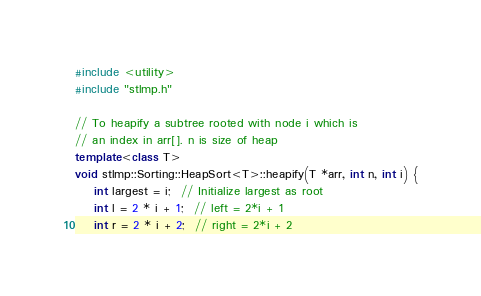Convert code to text. <code><loc_0><loc_0><loc_500><loc_500><_C++_>#include <utility>
#include "stlmp.h"

// To heapify a subtree rooted with node i which is
// an index in arr[]. n is size of heap
template<class T>
void stlmp::Sorting::HeapSort<T>::heapify(T *arr, int n, int i) {
    int largest = i;  // Initialize largest as root
    int l = 2 * i + 1;  // left = 2*i + 1
    int r = 2 * i + 2;  // right = 2*i + 2
</code> 